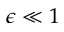Convert formula to latex. <formula><loc_0><loc_0><loc_500><loc_500>\epsilon \ll 1</formula> 